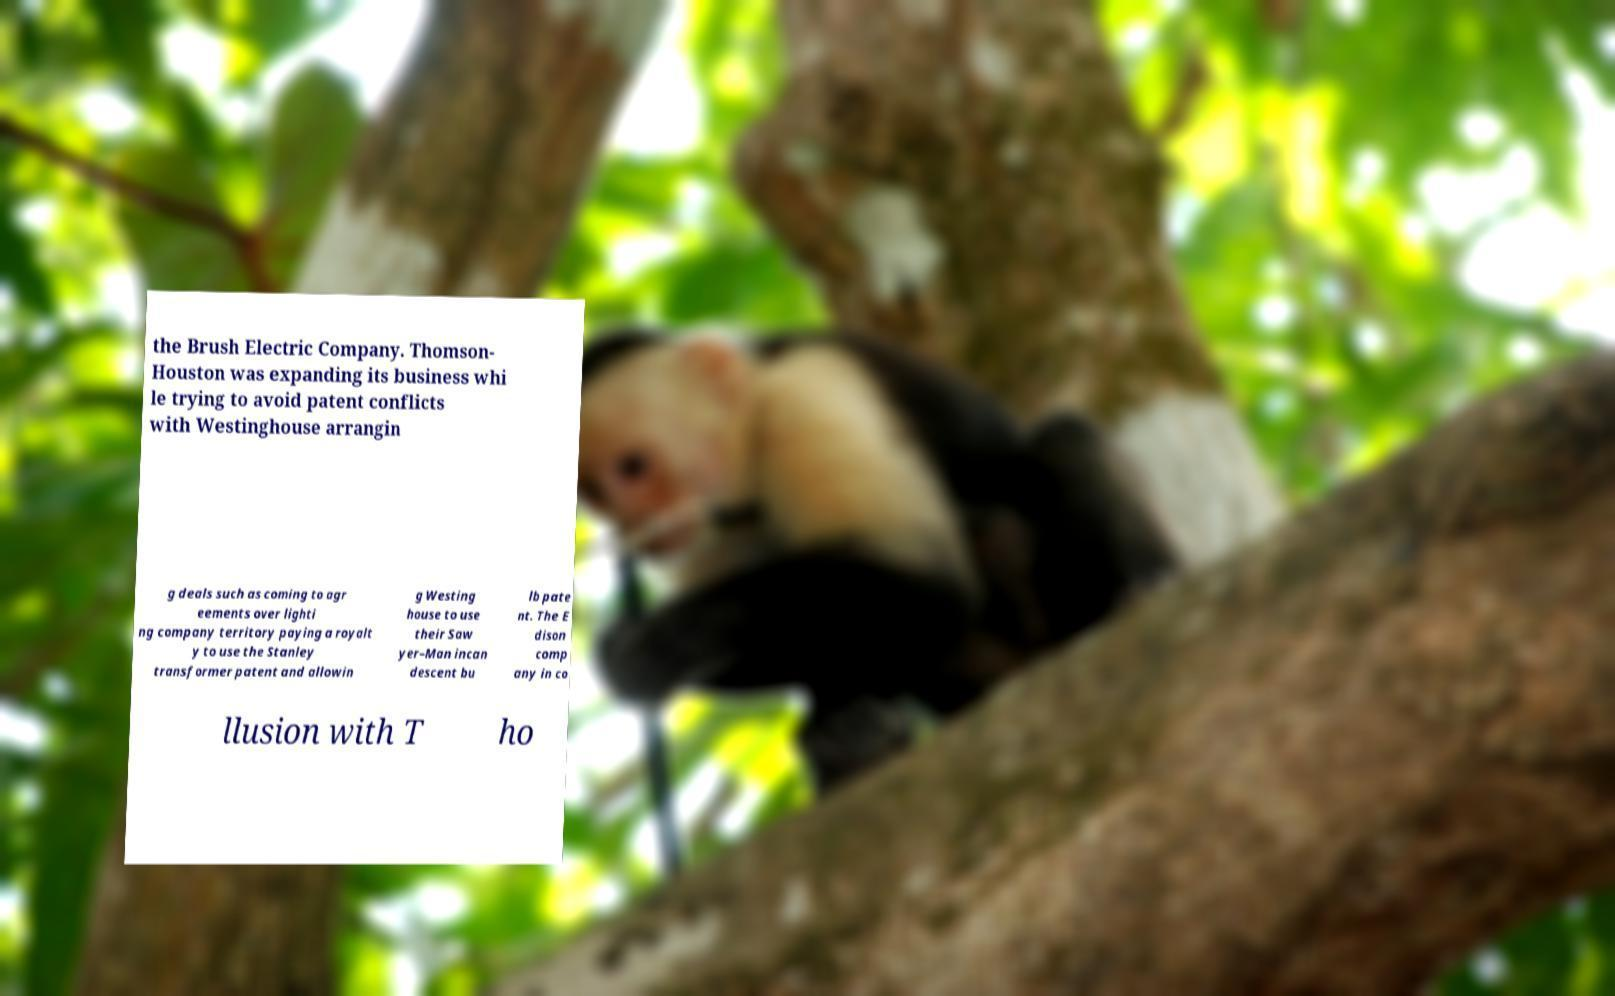Please identify and transcribe the text found in this image. the Brush Electric Company. Thomson- Houston was expanding its business whi le trying to avoid patent conflicts with Westinghouse arrangin g deals such as coming to agr eements over lighti ng company territory paying a royalt y to use the Stanley transformer patent and allowin g Westing house to use their Saw yer–Man incan descent bu lb pate nt. The E dison comp any in co llusion with T ho 